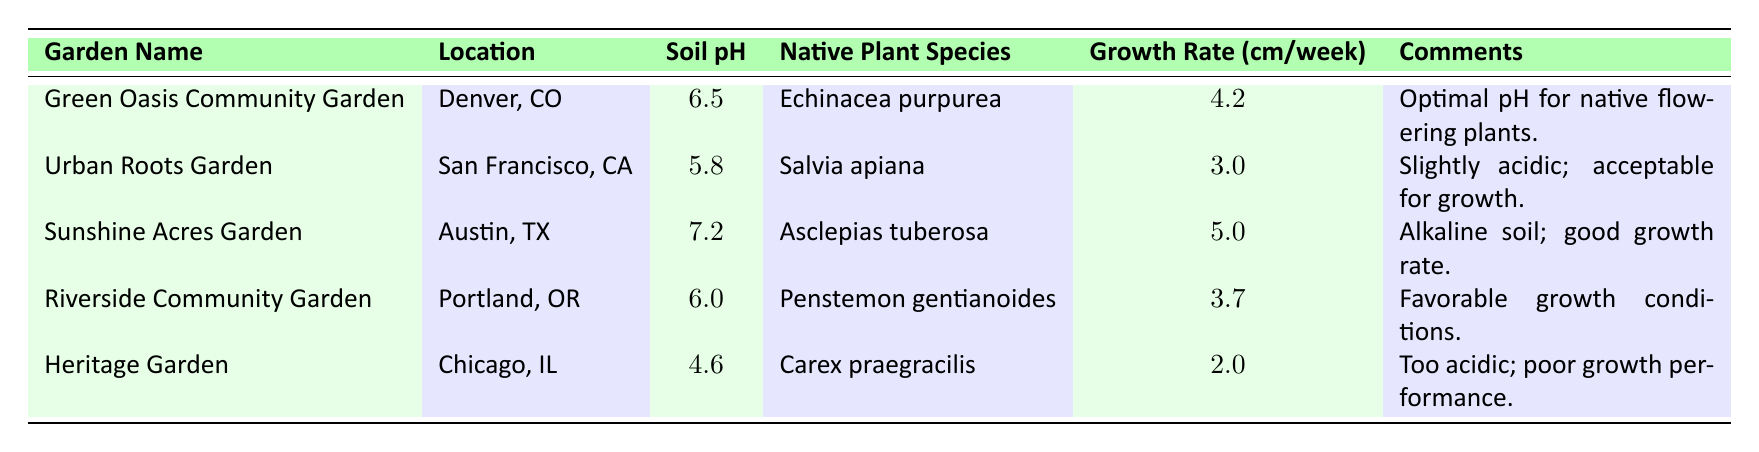What's the soil pH level in the Green Oasis Community Garden? According to the table, the soil pH level for the Green Oasis Community Garden is directly listed as 6.5.
Answer: 6.5 Which garden has the highest growth rate, and what is that rate? The highest growth rate is listed in the Sunshine Acres Garden with a rate of 5.0 cm per week.
Answer: 5.0 cm per week Is the soil pH in Urban Roots Garden considered acidic? The soil pH for the Urban Roots Garden is 5.8, which is below 6.0, indicating it is slightly acidic, confirming the comment in the table.
Answer: Yes What is the average growth rate of the native plants in the gardens listed? To calculate the average growth rate, sum the growth rates: 4.2 + 3.0 + 5.0 + 3.7 + 2.0 = 18.0. There are 5 gardens, so the average is 18.0 / 5 = 3.6 cm per week.
Answer: 3.6 cm per week Which garden has the lowest soil pH, and does it have a favorable growth comment? The Heritage Garden has the lowest soil pH level at 4.6. The comment states "Too acidic; poor growth performance," indicating unfavorable conditions.
Answer: Heritage Garden; No How many gardens have a soil pH above 6.0? The gardens with soil pH above 6.0 are: Green Oasis Community Garden (6.5), Sunshine Acres Garden (7.2), and Riverside Community Garden (6.0). This gives a total of 3 gardens.
Answer: 3 gardens Are all the native plant species listed returning good growth rates based on their comments? The comments indicate that while most gardens have favorable or acceptable conditions, the Heritage Garden specifically states poor growth performance, meaning not all are returning good growth rates.
Answer: No What is the difference in growth rates between the highest and lowest? The highest growth rate is from Sunshine Acres Garden at 5.0 cm/week, and the lowest is from Heritage Garden at 2.0 cm/week. The difference is 5.0 - 2.0 = 3.0 cm/week.
Answer: 3.0 cm/week 